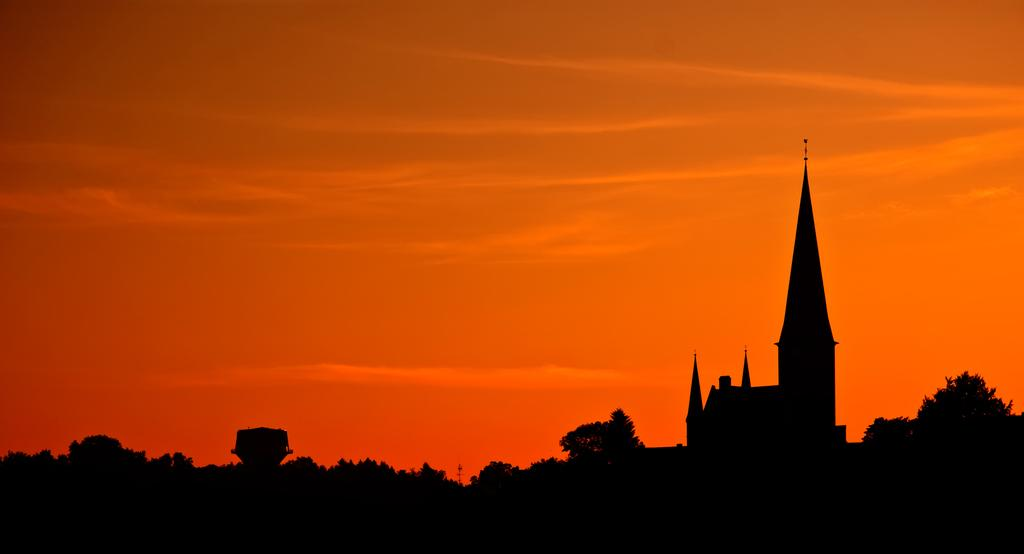What type of structures can be seen in the image? There are buildings and a tower in the image. What other natural elements are present in the image? There are trees in the image. What is visible in the background of the image? The sky is visible in the image. What is the color of the sky in the image? The sky has an orange color in the image. Can you see any grapes growing on the trees in the image? There are no grapes visible on the trees in the image. Are there any fairies flying around the tower in the image? There are no fairies present in the image. 